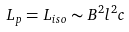<formula> <loc_0><loc_0><loc_500><loc_500>L _ { p } = L _ { i s o } \sim B ^ { 2 } l ^ { 2 } c</formula> 